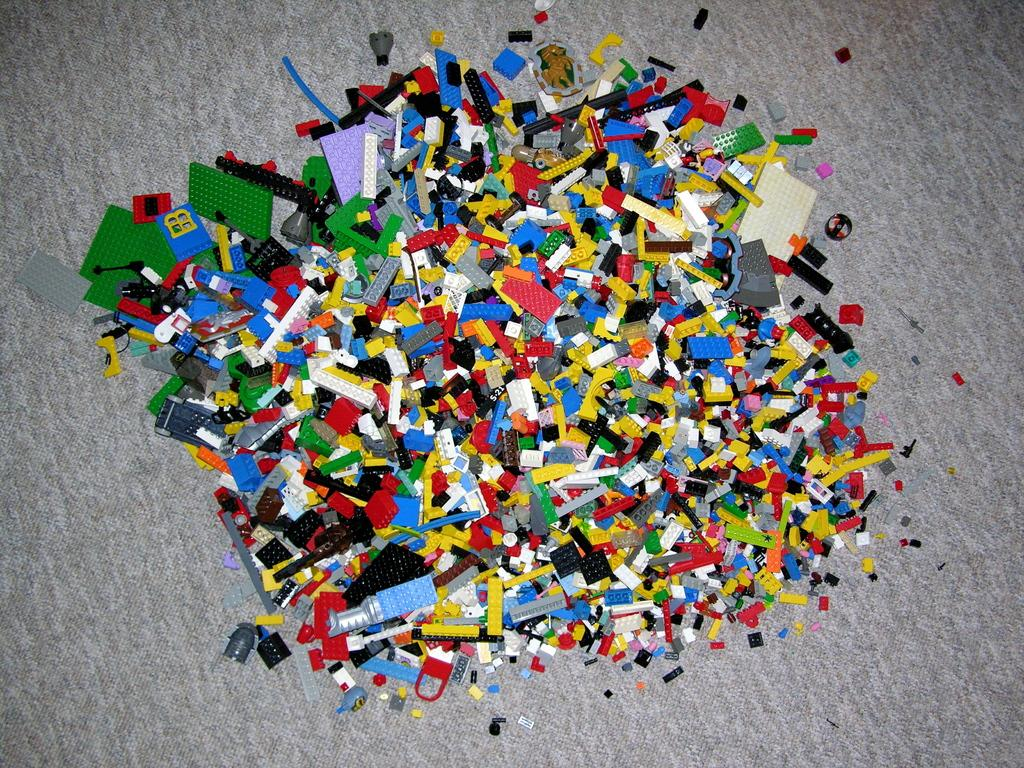What type of objects are in the image? There are toys in the image. Can you describe the toys in more detail? The toys are building blocks. What distinguishing features do the building blocks have? The building blocks have different colors and different sizes. Where are the building blocks located? The building blocks are on a carpet. What type of marble is being used to build a structure with the building blocks in the image? There is no marble present in the image; the building blocks are made of a different material. 